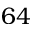<formula> <loc_0><loc_0><loc_500><loc_500>6 4</formula> 